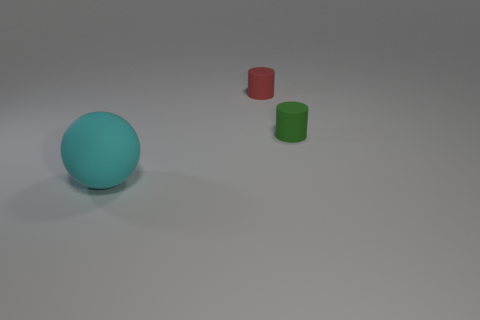How big is the matte thing that is in front of the tiny red rubber cylinder and behind the cyan rubber sphere?
Offer a terse response. Small. What size is the red object that is the same shape as the tiny green matte object?
Your answer should be compact. Small. What number of balls are small red rubber things or big matte objects?
Your answer should be compact. 1. Is the number of tiny red cylinders that are in front of the red cylinder the same as the number of large cyan balls that are right of the large cyan ball?
Make the answer very short. Yes. The large thing has what color?
Your response must be concise. Cyan. What number of objects are either tiny cylinders that are on the left side of the green cylinder or small green matte things?
Your answer should be compact. 2. Is the size of the object in front of the green cylinder the same as the matte thing right of the tiny red matte cylinder?
Provide a short and direct response. No. Is there any other thing that is made of the same material as the cyan object?
Provide a succinct answer. Yes. How many things are either things on the right side of the cyan object or things that are in front of the green cylinder?
Your response must be concise. 3. Does the big ball have the same material as the tiny object on the right side of the small red cylinder?
Your answer should be compact. Yes. 